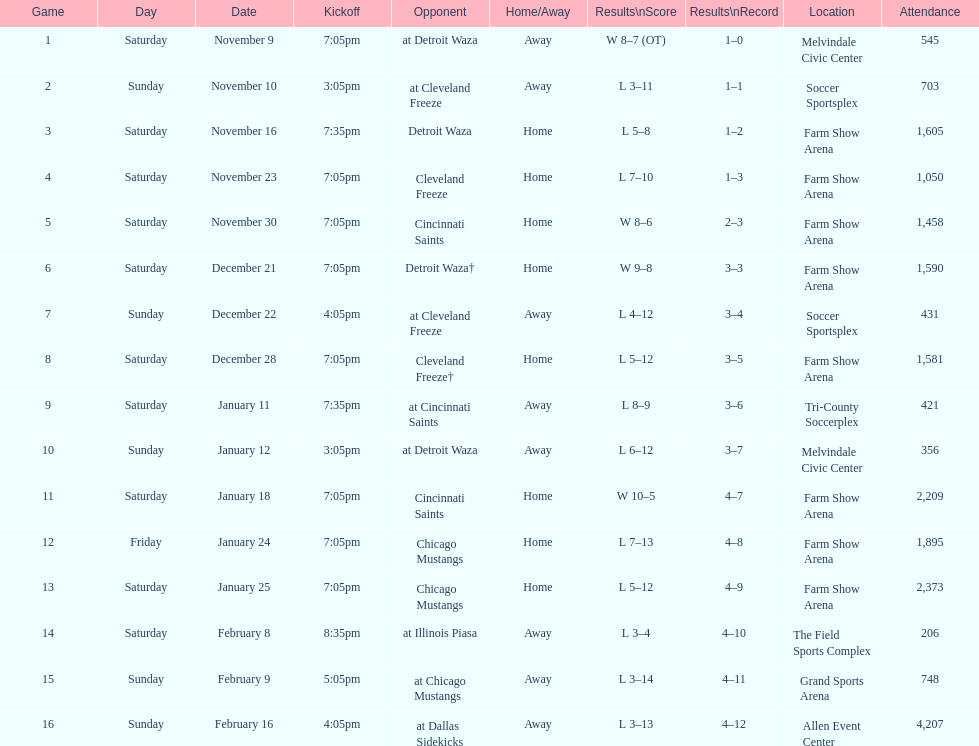Who was the first opponent on this list? Detroit Waza. Can you parse all the data within this table? {'header': ['Game', 'Day', 'Date', 'Kickoff', 'Opponent', 'Home/Away', 'Results\\nScore', 'Results\\nRecord', 'Location', 'Attendance'], 'rows': [['1', 'Saturday', 'November 9', '7:05pm', 'at Detroit Waza', 'Away', 'W 8–7 (OT)', '1–0', 'Melvindale Civic Center', '545'], ['2', 'Sunday', 'November 10', '3:05pm', 'at Cleveland Freeze', 'Away', 'L 3–11', '1–1', 'Soccer Sportsplex', '703'], ['3', 'Saturday', 'November 16', '7:35pm', 'Detroit Waza', 'Home', 'L 5–8', '1–2', 'Farm Show Arena', '1,605'], ['4', 'Saturday', 'November 23', '7:05pm', 'Cleveland Freeze', 'Home', 'L 7–10', '1–3', 'Farm Show Arena', '1,050'], ['5', 'Saturday', 'November 30', '7:05pm', 'Cincinnati Saints', 'Home', 'W 8–6', '2–3', 'Farm Show Arena', '1,458'], ['6', 'Saturday', 'December 21', '7:05pm', 'Detroit Waza†', 'Home', 'W 9–8', '3–3', 'Farm Show Arena', '1,590'], ['7', 'Sunday', 'December 22', '4:05pm', 'at Cleveland Freeze', 'Away', 'L 4–12', '3–4', 'Soccer Sportsplex', '431'], ['8', 'Saturday', 'December 28', '7:05pm', 'Cleveland Freeze†', 'Home', 'L 5–12', '3–5', 'Farm Show Arena', '1,581'], ['9', 'Saturday', 'January 11', '7:35pm', 'at Cincinnati Saints', 'Away', 'L 8–9', '3–6', 'Tri-County Soccerplex', '421'], ['10', 'Sunday', 'January 12', '3:05pm', 'at Detroit Waza', 'Away', 'L 6–12', '3–7', 'Melvindale Civic Center', '356'], ['11', 'Saturday', 'January 18', '7:05pm', 'Cincinnati Saints', 'Home', 'W 10–5', '4–7', 'Farm Show Arena', '2,209'], ['12', 'Friday', 'January 24', '7:05pm', 'Chicago Mustangs', 'Home', 'L 7–13', '4–8', 'Farm Show Arena', '1,895'], ['13', 'Saturday', 'January 25', '7:05pm', 'Chicago Mustangs', 'Home', 'L 5–12', '4–9', 'Farm Show Arena', '2,373'], ['14', 'Saturday', 'February 8', '8:35pm', 'at Illinois Piasa', 'Away', 'L 3–4', '4–10', 'The Field Sports Complex', '206'], ['15', 'Sunday', 'February 9', '5:05pm', 'at Chicago Mustangs', 'Away', 'L 3–14', '4–11', 'Grand Sports Arena', '748'], ['16', 'Sunday', 'February 16', '4:05pm', 'at Dallas Sidekicks', 'Away', 'L 3–13', '4–12', 'Allen Event Center', '4,207']]} 